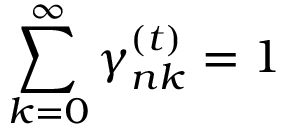Convert formula to latex. <formula><loc_0><loc_0><loc_500><loc_500>\sum _ { k = 0 } ^ { \infty } \gamma _ { n k } ^ { ( t ) } = 1</formula> 